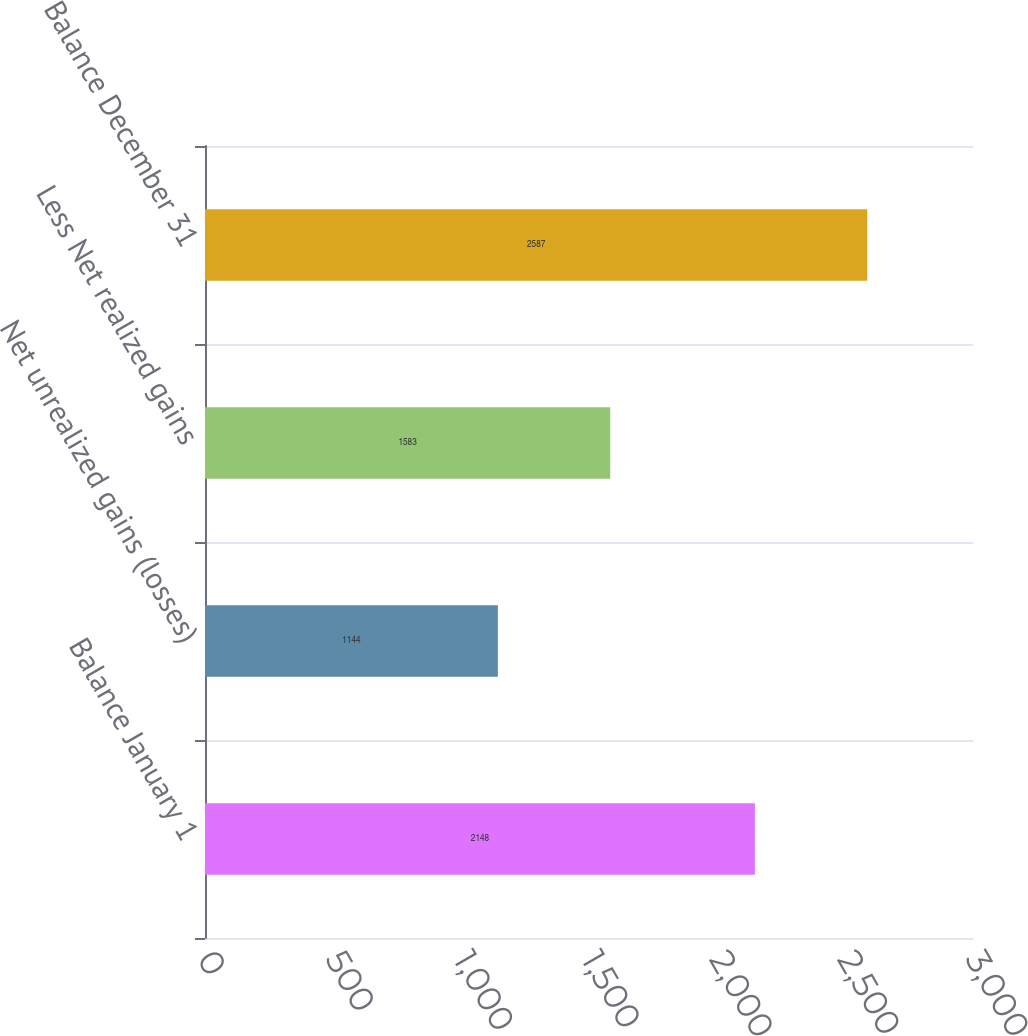Convert chart. <chart><loc_0><loc_0><loc_500><loc_500><bar_chart><fcel>Balance January 1<fcel>Net unrealized gains (losses)<fcel>Less Net realized gains<fcel>Balance December 31<nl><fcel>2148<fcel>1144<fcel>1583<fcel>2587<nl></chart> 